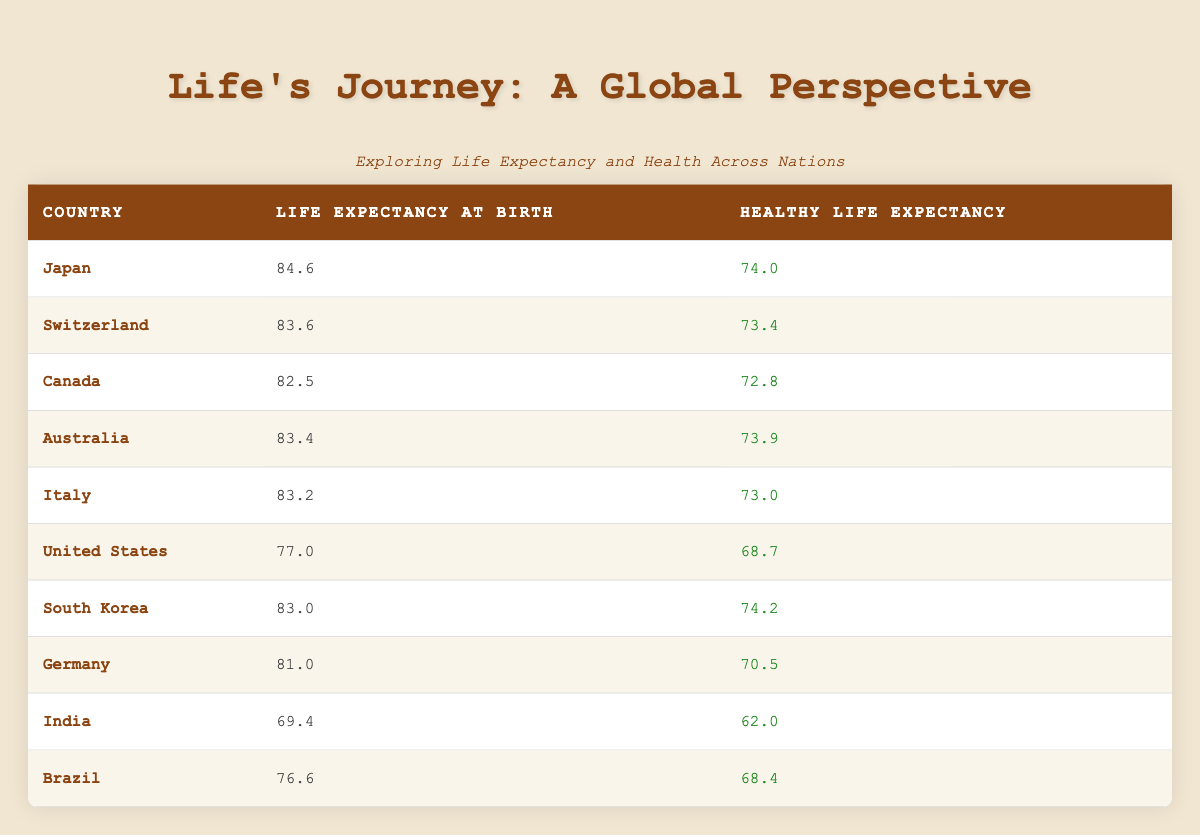What is the life expectancy at birth for Japan? The table lists Japan's life expectancy at birth as 84.6 years. This information can be directly retrieved from the corresponding row in the table.
Answer: 84.6 Which country has the highest healthy life expectancy? By examining the healthy life expectancy values in the table, Japan has 74.0, Switzerland has 73.4, and South Korea has 74.2. South Korea has the highest value of 74.2.
Answer: South Korea What is the difference in life expectancy at birth between the United States and Germany? The life expectancy at birth for the United States is 77.0 years, and for Germany, it is 81.0 years. Subtracting 77.0 from 81.0 gives a difference of 4.0 years.
Answer: 4.0 Is the healthy life expectancy in Brazil greater than that in India? Brazil has a healthy life expectancy of 68.4 years, while India has 62.0 years. Since 68.4 is greater than 62.0, the answer is yes.
Answer: Yes What is the average life expectancy at birth of the top three countries? The top three countries by life expectancy at birth are Japan (84.6), Switzerland (83.6), and Australia (83.4). Adding these values together gives 251.6, and dividing by 3 results in an average of approximately 83.87.
Answer: 83.87 